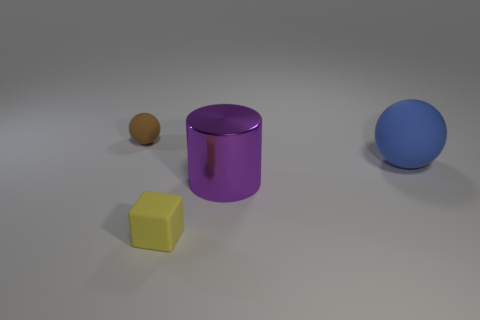What number of objects are rubber balls on the left side of the yellow rubber object or yellow blocks?
Provide a short and direct response. 2. How many small yellow rubber cubes are left of the small rubber thing on the right side of the tiny object on the left side of the tiny yellow matte object?
Your answer should be compact. 0. Is there anything else that has the same size as the purple thing?
Offer a terse response. Yes. The big object that is left of the ball on the right side of the brown rubber ball on the left side of the purple object is what shape?
Offer a terse response. Cylinder. What number of other things are there of the same color as the block?
Provide a short and direct response. 0. What is the shape of the tiny object behind the sphere that is on the right side of the cube?
Provide a short and direct response. Sphere. What number of big spheres are behind the rubber block?
Your answer should be very brief. 1. Is there a large sphere that has the same material as the small yellow object?
Your answer should be very brief. Yes. There is a brown ball that is the same size as the rubber block; what is it made of?
Offer a very short reply. Rubber. What size is the thing that is both to the left of the shiny thing and behind the tiny yellow matte cube?
Offer a terse response. Small. 